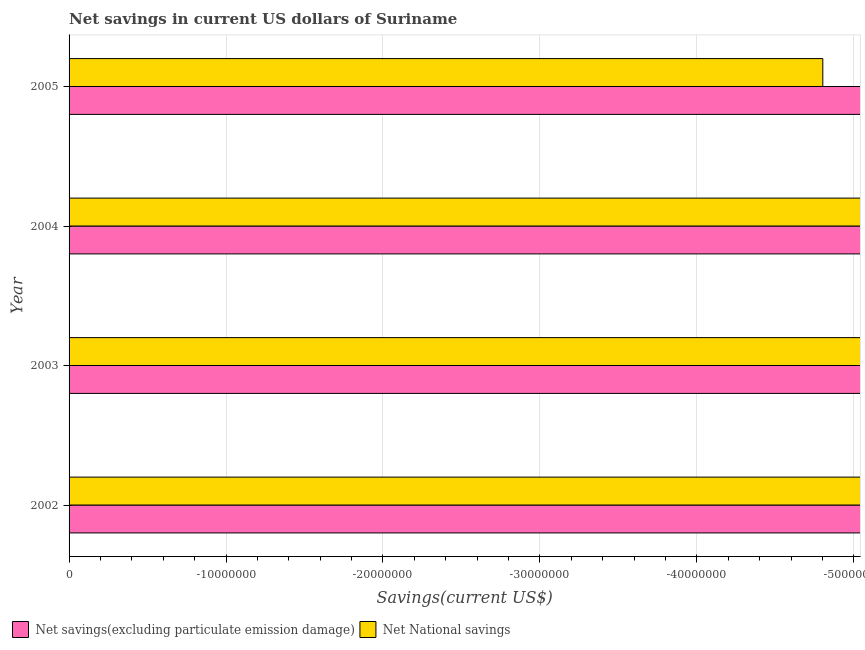Are the number of bars on each tick of the Y-axis equal?
Give a very brief answer. Yes. How many bars are there on the 1st tick from the bottom?
Provide a succinct answer. 0. In how many cases, is the number of bars for a given year not equal to the number of legend labels?
Provide a succinct answer. 4. What is the average net savings(excluding particulate emission damage) per year?
Keep it short and to the point. 0. In how many years, is the net national savings greater than -22000000 US$?
Ensure brevity in your answer.  0. In how many years, is the net savings(excluding particulate emission damage) greater than the average net savings(excluding particulate emission damage) taken over all years?
Provide a succinct answer. 0. Where does the legend appear in the graph?
Ensure brevity in your answer.  Bottom left. How many legend labels are there?
Your answer should be very brief. 2. How are the legend labels stacked?
Provide a short and direct response. Horizontal. What is the title of the graph?
Provide a short and direct response. Net savings in current US dollars of Suriname. Does "IMF concessional" appear as one of the legend labels in the graph?
Provide a succinct answer. No. What is the label or title of the X-axis?
Offer a terse response. Savings(current US$). What is the label or title of the Y-axis?
Your response must be concise. Year. What is the Savings(current US$) in Net National savings in 2005?
Make the answer very short. 0. What is the total Savings(current US$) of Net National savings in the graph?
Make the answer very short. 0. What is the average Savings(current US$) in Net savings(excluding particulate emission damage) per year?
Provide a short and direct response. 0. What is the average Savings(current US$) in Net National savings per year?
Provide a succinct answer. 0. 